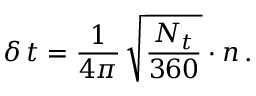<formula> <loc_0><loc_0><loc_500><loc_500>\, \delta \, t = \frac { 1 } { 4 \pi } \, \sqrt { \frac { N _ { t } } { 3 6 0 } } \cdot n \, .</formula> 